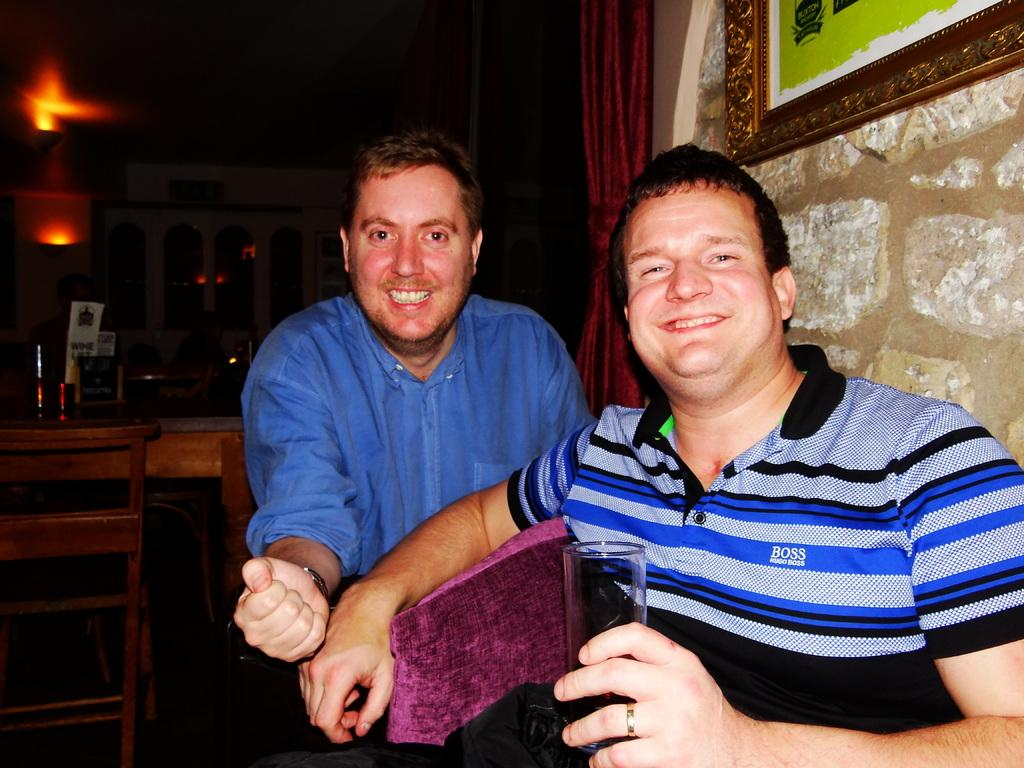How many people are in the image? There are two persons in the image. What are the persons doing in the image? The persons are sitting on a chair and holding a glass. What is the emotional state of the persons in the image? The persons are smiling in the image. What type of furniture is present in the image? There are chairs and tables in the image. What can be seen in the background of the image? There are lights visible in the image, and there is a picture on the wall. How does the shade of the chair move in the image? There is no shade of a chair present in the image; it is a solid chair. 